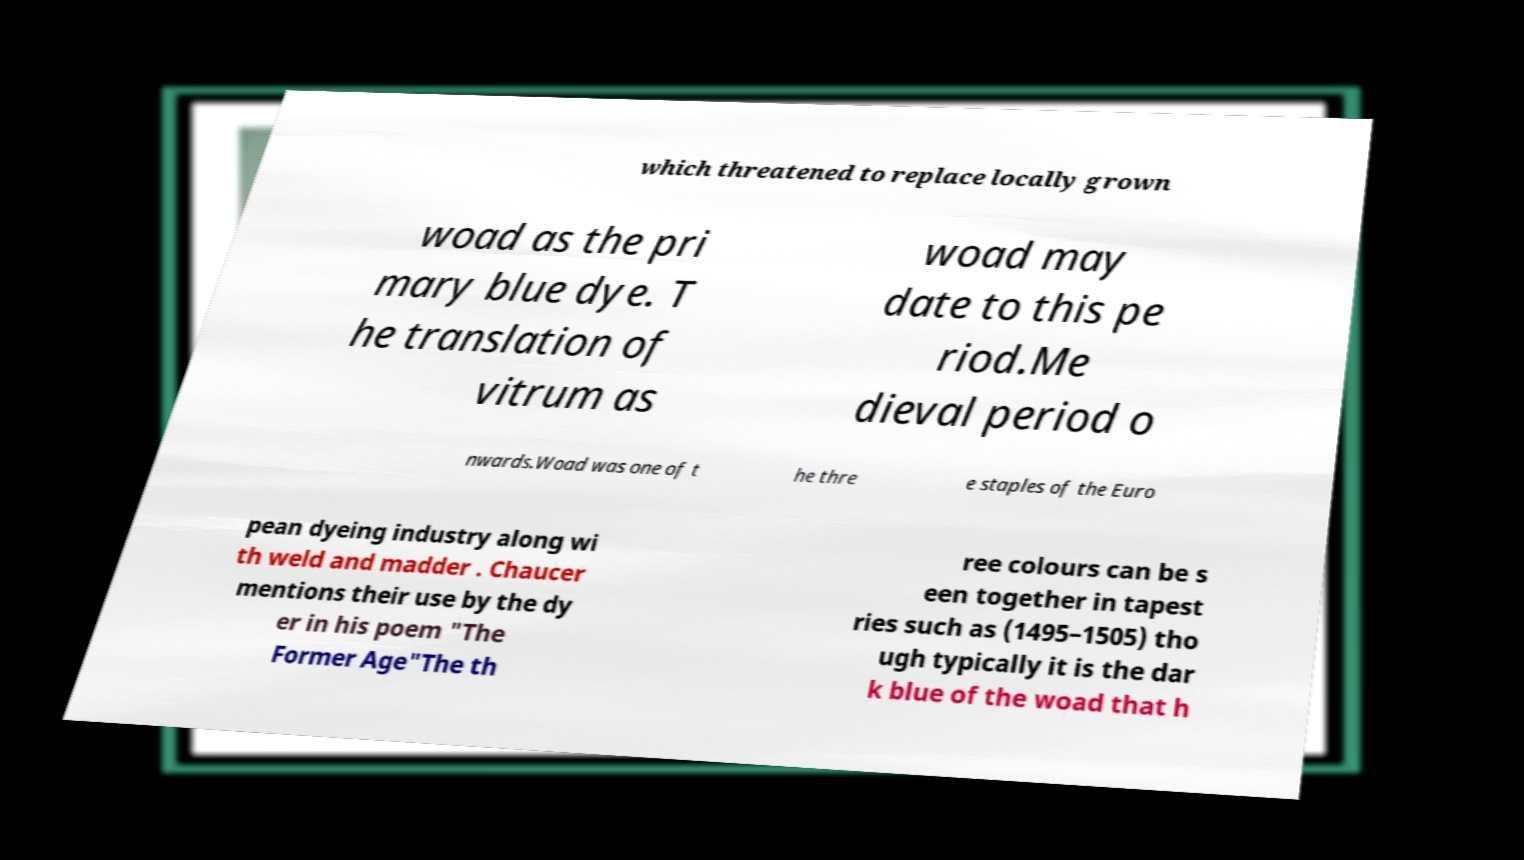Could you assist in decoding the text presented in this image and type it out clearly? which threatened to replace locally grown woad as the pri mary blue dye. T he translation of vitrum as woad may date to this pe riod.Me dieval period o nwards.Woad was one of t he thre e staples of the Euro pean dyeing industry along wi th weld and madder . Chaucer mentions their use by the dy er in his poem "The Former Age"The th ree colours can be s een together in tapest ries such as (1495–1505) tho ugh typically it is the dar k blue of the woad that h 